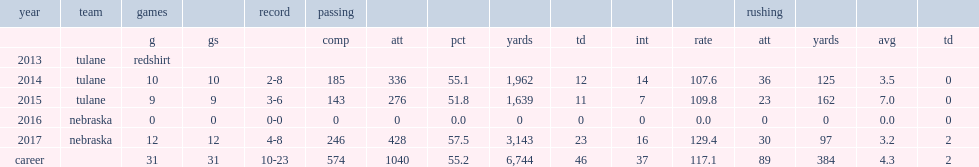How many passing yards did lee get in 2014? 1962.0. 